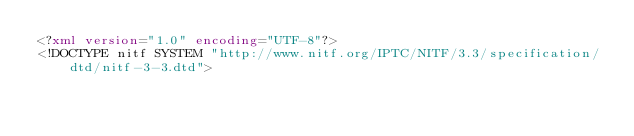<code> <loc_0><loc_0><loc_500><loc_500><_XML_><?xml version="1.0" encoding="UTF-8"?>
<!DOCTYPE nitf SYSTEM "http://www.nitf.org/IPTC/NITF/3.3/specification/dtd/nitf-3-3.dtd"></code> 